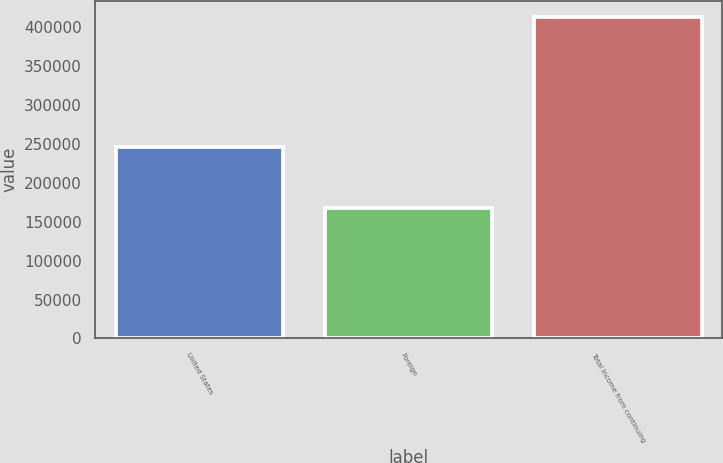Convert chart to OTSL. <chart><loc_0><loc_0><loc_500><loc_500><bar_chart><fcel>United States<fcel>Foreign<fcel>Total income from continuing<nl><fcel>245745<fcel>166950<fcel>412695<nl></chart> 